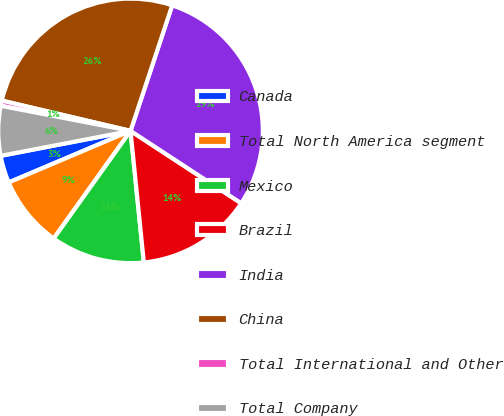Convert chart. <chart><loc_0><loc_0><loc_500><loc_500><pie_chart><fcel>Canada<fcel>Total North America segment<fcel>Mexico<fcel>Brazil<fcel>India<fcel>China<fcel>Total International and Other<fcel>Total Company<nl><fcel>3.35%<fcel>8.76%<fcel>11.47%<fcel>14.18%<fcel>29.12%<fcel>26.42%<fcel>0.64%<fcel>6.06%<nl></chart> 